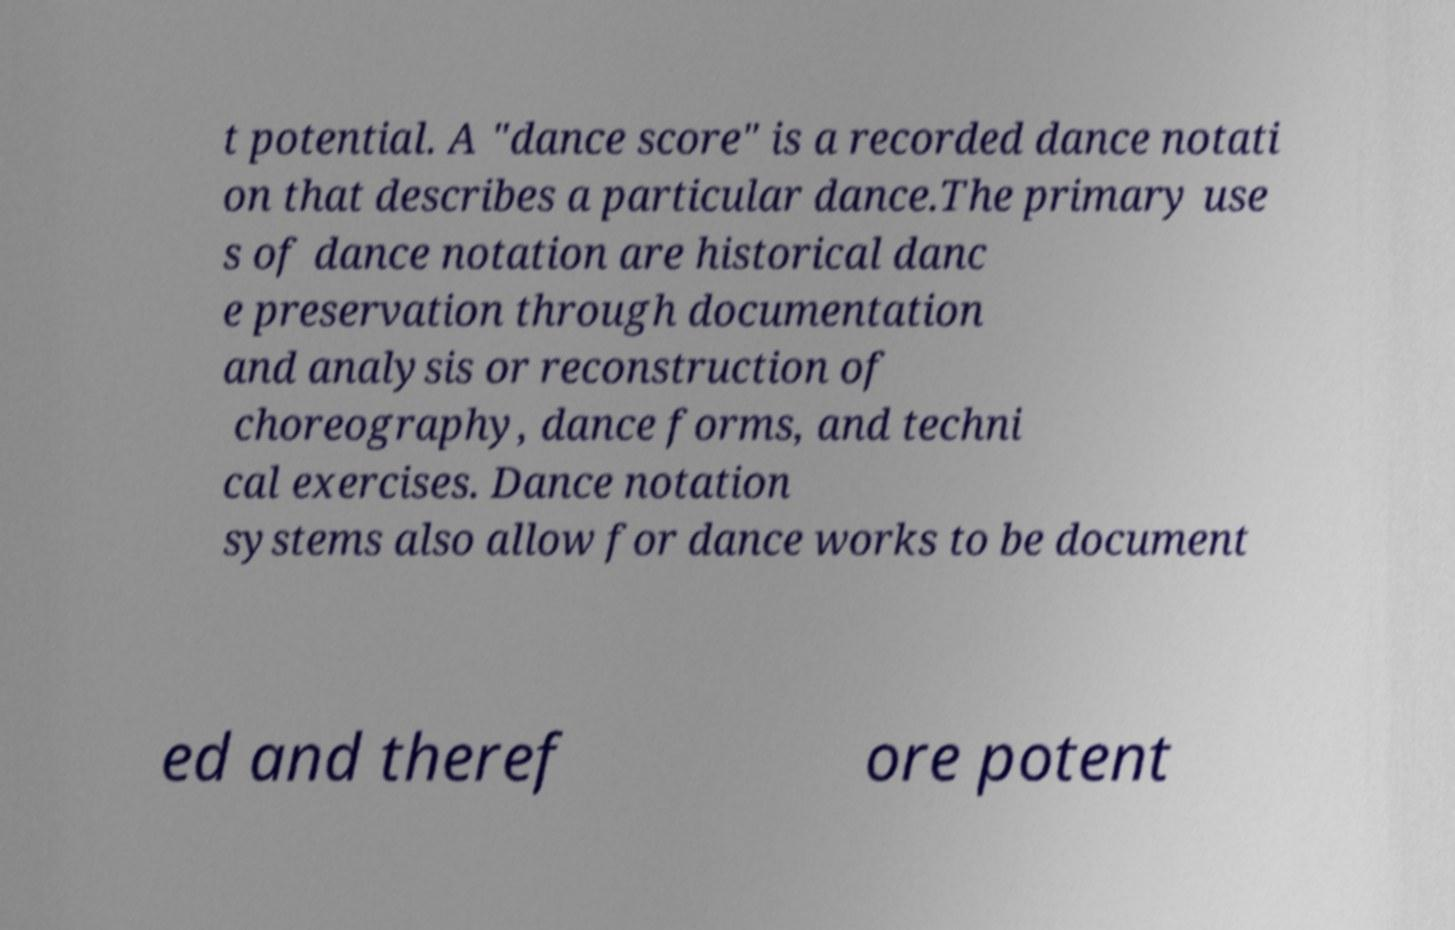I need the written content from this picture converted into text. Can you do that? t potential. A "dance score" is a recorded dance notati on that describes a particular dance.The primary use s of dance notation are historical danc e preservation through documentation and analysis or reconstruction of choreography, dance forms, and techni cal exercises. Dance notation systems also allow for dance works to be document ed and theref ore potent 